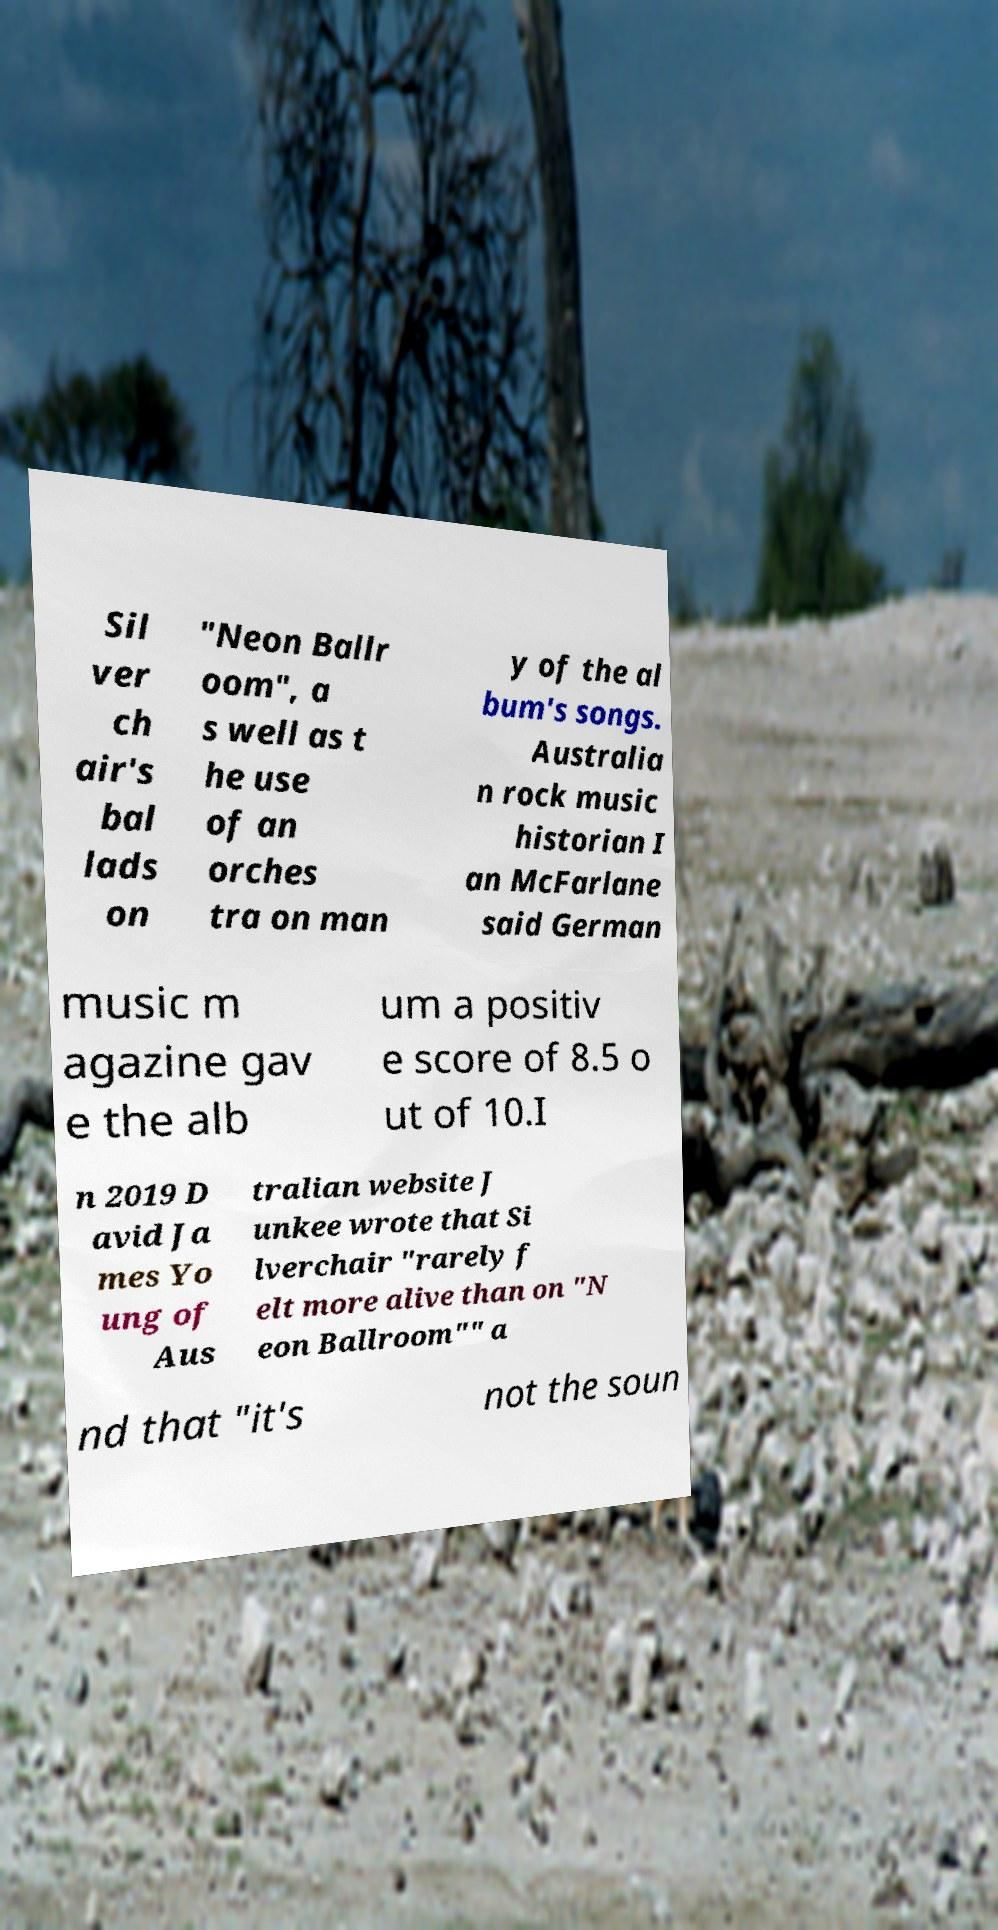Please read and relay the text visible in this image. What does it say? Sil ver ch air's bal lads on "Neon Ballr oom", a s well as t he use of an orches tra on man y of the al bum's songs. Australia n rock music historian I an McFarlane said German music m agazine gav e the alb um a positiv e score of 8.5 o ut of 10.I n 2019 D avid Ja mes Yo ung of Aus tralian website J unkee wrote that Si lverchair "rarely f elt more alive than on "N eon Ballroom"" a nd that "it's not the soun 